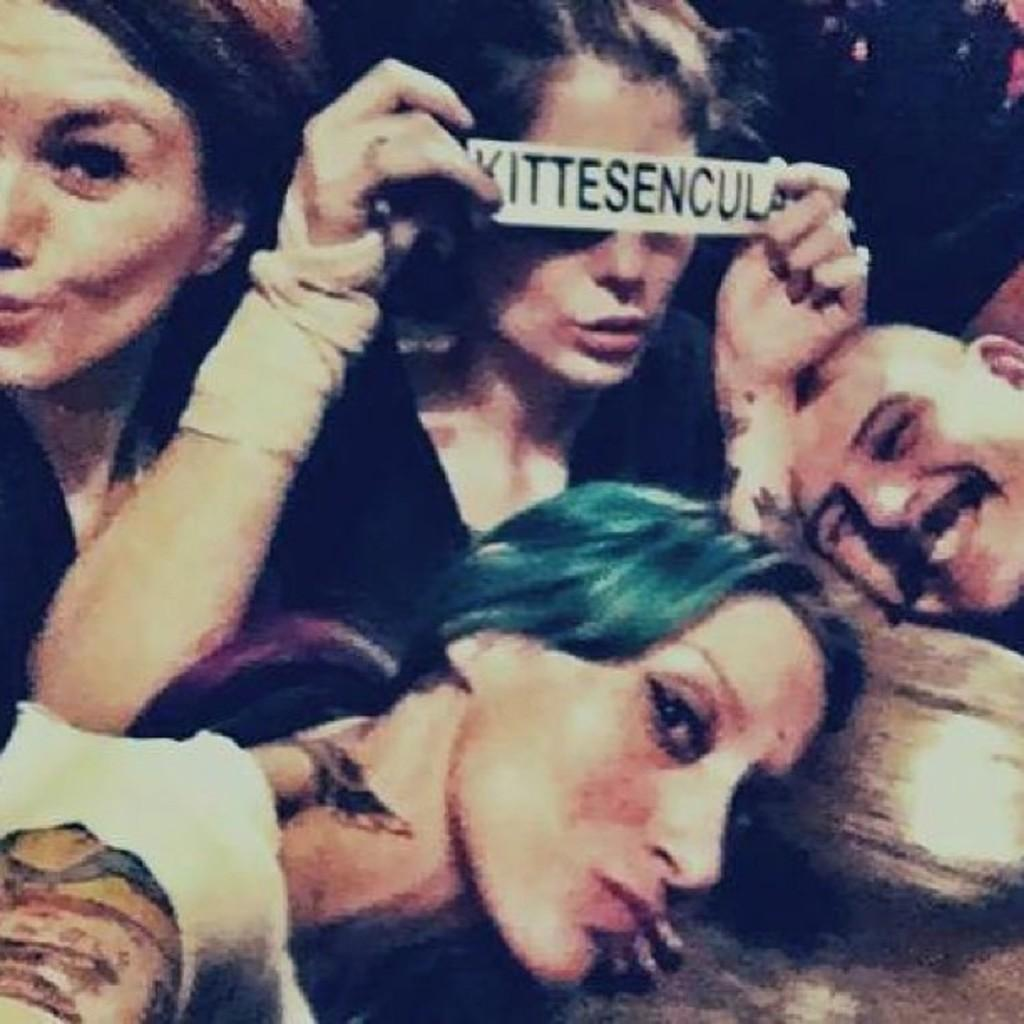What can be observed about the people in the image? There is a group of ladies and a man in the image, and they are all smiling. What is the woman holding in her hands? The woman is holding a sticker in her hands. What type of drug is the man holding in the image? There is no drug present in the image; the man is simply smiling. How many dogs are visible in the image? There are no dogs present in the image. 